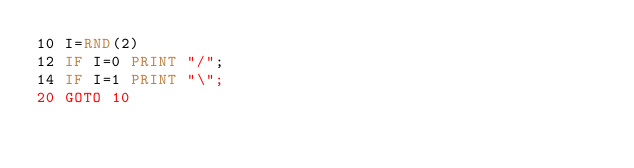Convert code to text. <code><loc_0><loc_0><loc_500><loc_500><_VisualBasic_>10 I=RND(2)
12 IF I=0 PRINT "/";
14 IF I=1 PRINT "\";
20 GOTO 10</code> 